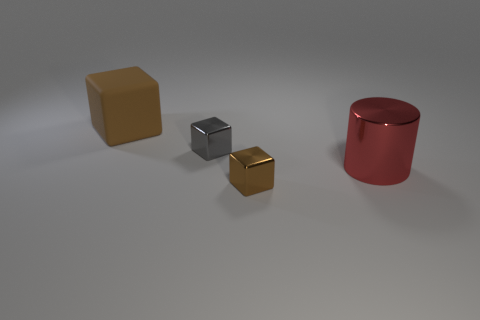Subtract all tiny gray metallic blocks. How many blocks are left? 2 Subtract all green cylinders. How many brown blocks are left? 2 Subtract 1 blocks. How many blocks are left? 2 Add 2 cubes. How many objects exist? 6 Subtract all red cubes. Subtract all purple balls. How many cubes are left? 3 Subtract 0 blue cylinders. How many objects are left? 4 Subtract all blocks. How many objects are left? 1 Subtract all big blue shiny cubes. Subtract all big cylinders. How many objects are left? 3 Add 1 small brown metallic blocks. How many small brown metallic blocks are left? 2 Add 3 large matte cubes. How many large matte cubes exist? 4 